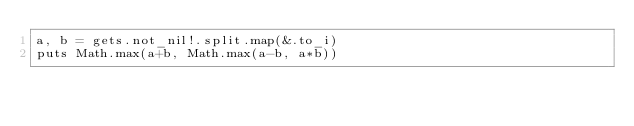<code> <loc_0><loc_0><loc_500><loc_500><_Crystal_>a, b = gets.not_nil!.split.map(&.to_i)
puts Math.max(a+b, Math.max(a-b, a*b))</code> 